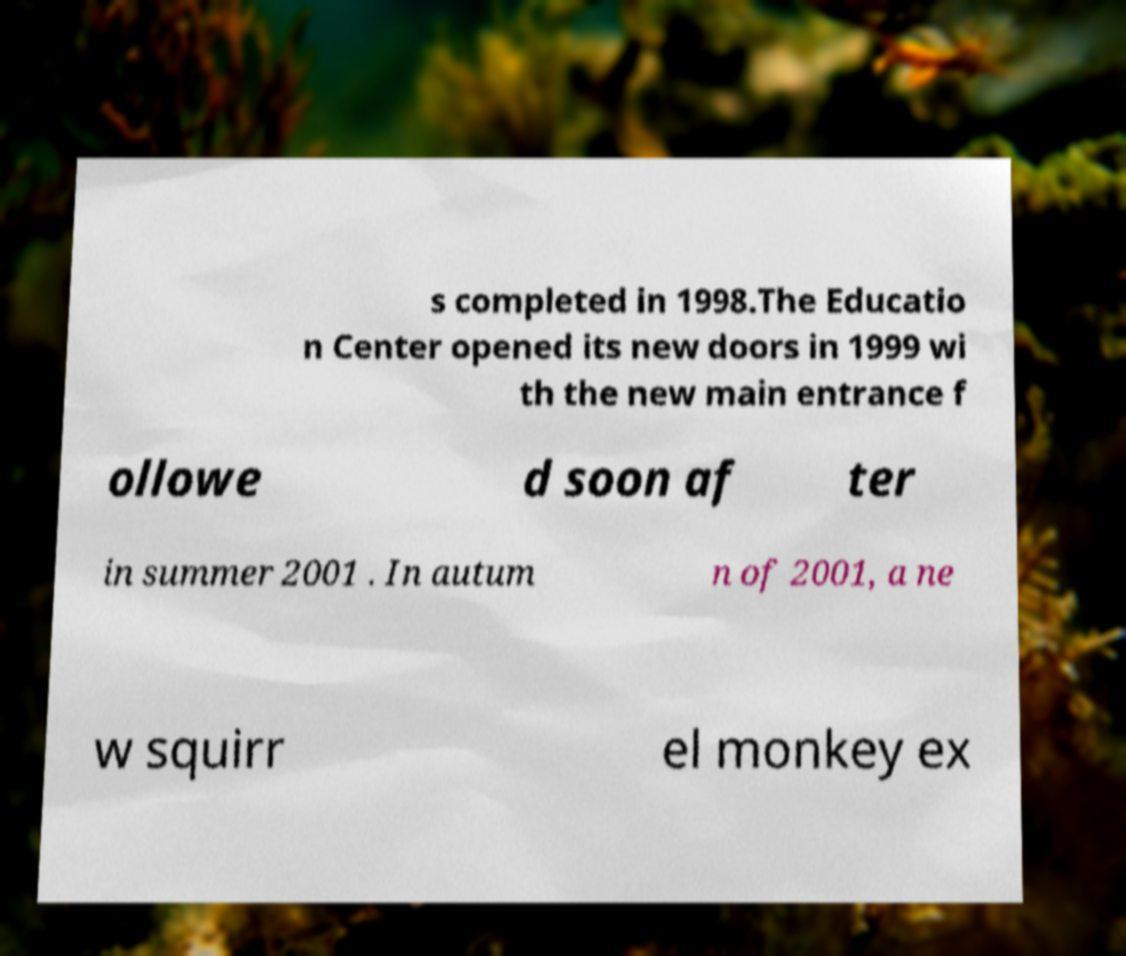Can you accurately transcribe the text from the provided image for me? s completed in 1998.The Educatio n Center opened its new doors in 1999 wi th the new main entrance f ollowe d soon af ter in summer 2001 . In autum n of 2001, a ne w squirr el monkey ex 